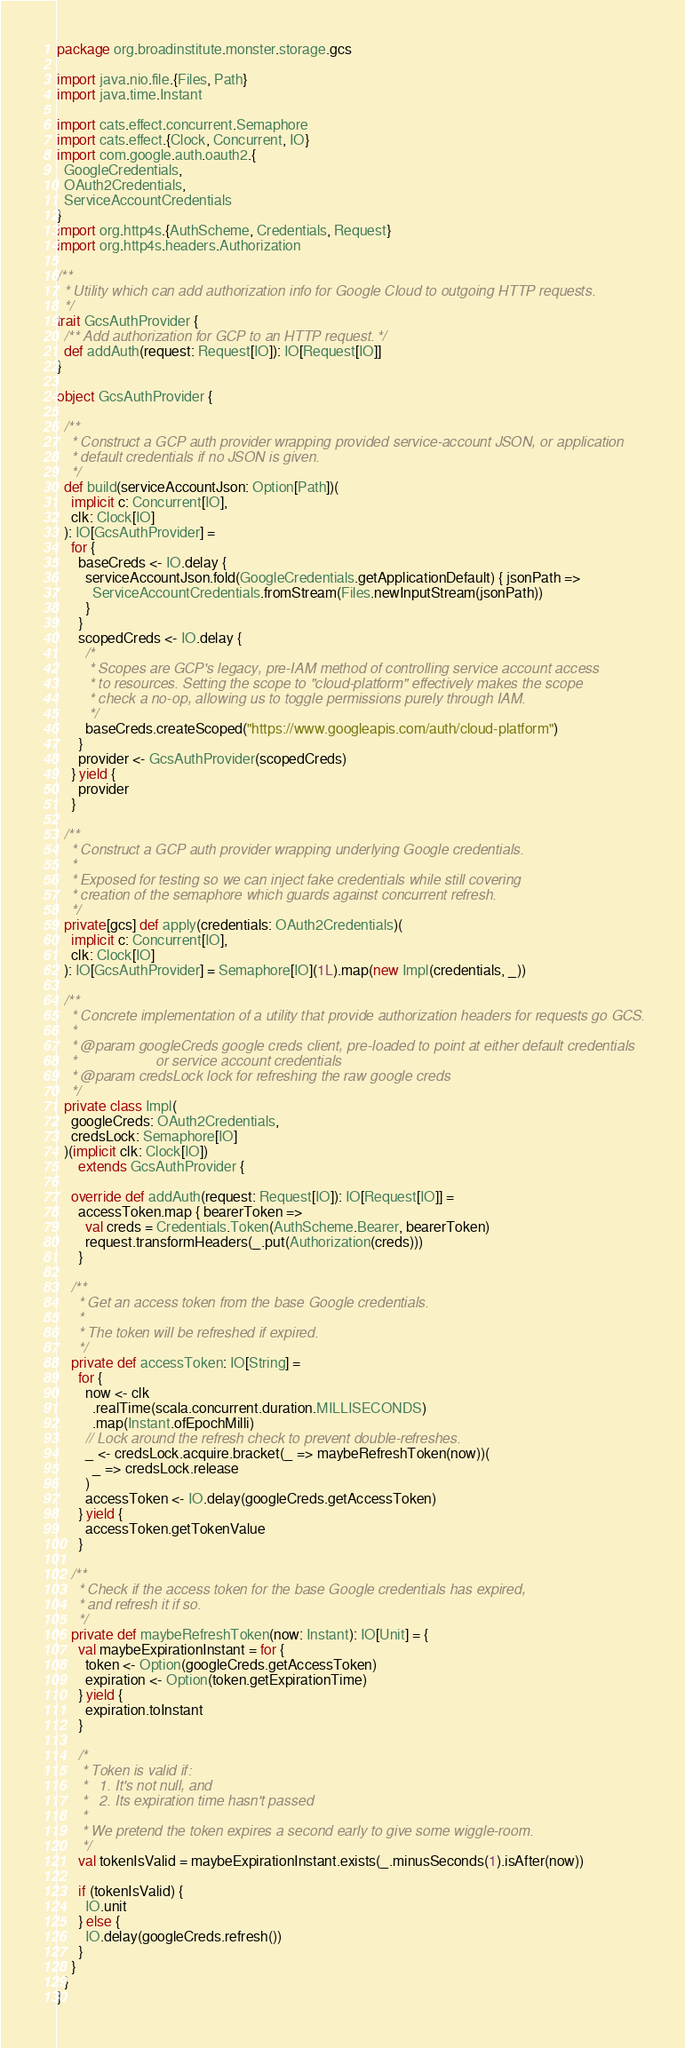Convert code to text. <code><loc_0><loc_0><loc_500><loc_500><_Scala_>package org.broadinstitute.monster.storage.gcs

import java.nio.file.{Files, Path}
import java.time.Instant

import cats.effect.concurrent.Semaphore
import cats.effect.{Clock, Concurrent, IO}
import com.google.auth.oauth2.{
  GoogleCredentials,
  OAuth2Credentials,
  ServiceAccountCredentials
}
import org.http4s.{AuthScheme, Credentials, Request}
import org.http4s.headers.Authorization

/**
  * Utility which can add authorization info for Google Cloud to outgoing HTTP requests.
  */
trait GcsAuthProvider {
  /** Add authorization for GCP to an HTTP request. */
  def addAuth(request: Request[IO]): IO[Request[IO]]
}

object GcsAuthProvider {

  /**
    * Construct a GCP auth provider wrapping provided service-account JSON, or application
    * default credentials if no JSON is given.
    */
  def build(serviceAccountJson: Option[Path])(
    implicit c: Concurrent[IO],
    clk: Clock[IO]
  ): IO[GcsAuthProvider] =
    for {
      baseCreds <- IO.delay {
        serviceAccountJson.fold(GoogleCredentials.getApplicationDefault) { jsonPath =>
          ServiceAccountCredentials.fromStream(Files.newInputStream(jsonPath))
        }
      }
      scopedCreds <- IO.delay {
        /*
         * Scopes are GCP's legacy, pre-IAM method of controlling service account access
         * to resources. Setting the scope to "cloud-platform" effectively makes the scope
         * check a no-op, allowing us to toggle permissions purely through IAM.
         */
        baseCreds.createScoped("https://www.googleapis.com/auth/cloud-platform")
      }
      provider <- GcsAuthProvider(scopedCreds)
    } yield {
      provider
    }

  /**
    * Construct a GCP auth provider wrapping underlying Google credentials.
    *
    * Exposed for testing so we can inject fake credentials while still covering
    * creation of the semaphore which guards against concurrent refresh.
    */
  private[gcs] def apply(credentials: OAuth2Credentials)(
    implicit c: Concurrent[IO],
    clk: Clock[IO]
  ): IO[GcsAuthProvider] = Semaphore[IO](1L).map(new Impl(credentials, _))

  /**
    * Concrete implementation of a utility that provide authorization headers for requests go GCS.
    *
    * @param googleCreds google creds client, pre-loaded to point at either default credentials
    *                    or service account credentials
    * @param credsLock lock for refreshing the raw google creds
    */
  private class Impl(
    googleCreds: OAuth2Credentials,
    credsLock: Semaphore[IO]
  )(implicit clk: Clock[IO])
      extends GcsAuthProvider {

    override def addAuth(request: Request[IO]): IO[Request[IO]] =
      accessToken.map { bearerToken =>
        val creds = Credentials.Token(AuthScheme.Bearer, bearerToken)
        request.transformHeaders(_.put(Authorization(creds)))
      }

    /**
      * Get an access token from the base Google credentials.
      *
      * The token will be refreshed if expired.
      */
    private def accessToken: IO[String] =
      for {
        now <- clk
          .realTime(scala.concurrent.duration.MILLISECONDS)
          .map(Instant.ofEpochMilli)
        // Lock around the refresh check to prevent double-refreshes.
        _ <- credsLock.acquire.bracket(_ => maybeRefreshToken(now))(
          _ => credsLock.release
        )
        accessToken <- IO.delay(googleCreds.getAccessToken)
      } yield {
        accessToken.getTokenValue
      }

    /**
      * Check if the access token for the base Google credentials has expired,
      * and refresh it if so.
      */
    private def maybeRefreshToken(now: Instant): IO[Unit] = {
      val maybeExpirationInstant = for {
        token <- Option(googleCreds.getAccessToken)
        expiration <- Option(token.getExpirationTime)
      } yield {
        expiration.toInstant
      }

      /*
       * Token is valid if:
       *   1. It's not null, and
       *   2. Its expiration time hasn't passed
       *
       * We pretend the token expires a second early to give some wiggle-room.
       */
      val tokenIsValid = maybeExpirationInstant.exists(_.minusSeconds(1).isAfter(now))

      if (tokenIsValid) {
        IO.unit
      } else {
        IO.delay(googleCreds.refresh())
      }
    }
  }
}
</code> 